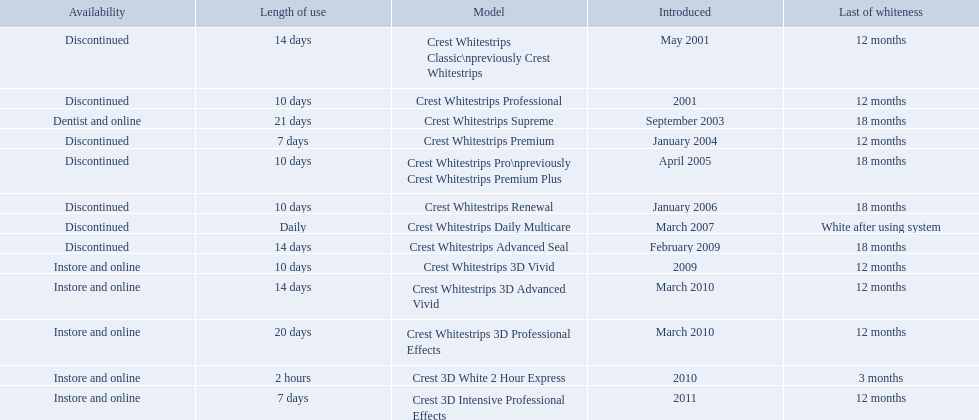What are all the models? Crest Whitestrips Classic\npreviously Crest Whitestrips, Crest Whitestrips Professional, Crest Whitestrips Supreme, Crest Whitestrips Premium, Crest Whitestrips Pro\npreviously Crest Whitestrips Premium Plus, Crest Whitestrips Renewal, Crest Whitestrips Daily Multicare, Crest Whitestrips Advanced Seal, Crest Whitestrips 3D Vivid, Crest Whitestrips 3D Advanced Vivid, Crest Whitestrips 3D Professional Effects, Crest 3D White 2 Hour Express, Crest 3D Intensive Professional Effects. Of these, for which can a ratio be calculated for 'length of use' to 'last of whiteness'? Crest Whitestrips Classic\npreviously Crest Whitestrips, Crest Whitestrips Professional, Crest Whitestrips Supreme, Crest Whitestrips Premium, Crest Whitestrips Pro\npreviously Crest Whitestrips Premium Plus, Crest Whitestrips Renewal, Crest Whitestrips Advanced Seal, Crest Whitestrips 3D Vivid, Crest Whitestrips 3D Advanced Vivid, Crest Whitestrips 3D Professional Effects, Crest 3D White 2 Hour Express, Crest 3D Intensive Professional Effects. Which has the highest ratio? Crest Whitestrips Supreme. 